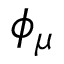Convert formula to latex. <formula><loc_0><loc_0><loc_500><loc_500>\phi _ { \mu }</formula> 